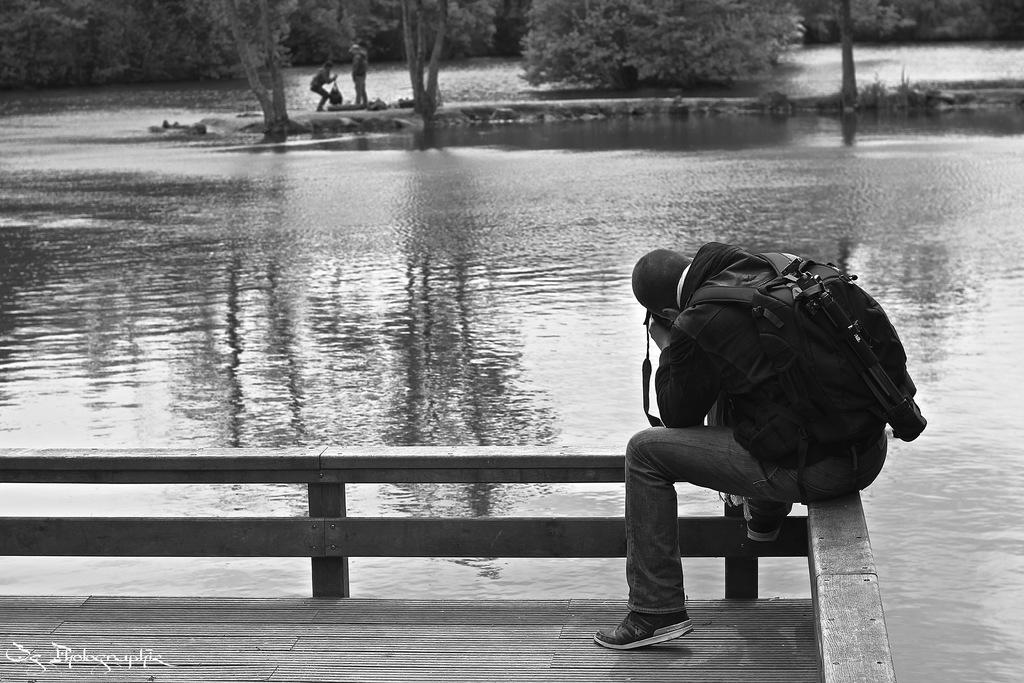Could you give a brief overview of what you see in this image? In this picture we can see some text in the bottom left. We can see a person wearing a bag and sitting on an object. There is the water. We can see two people and trees in the background. 